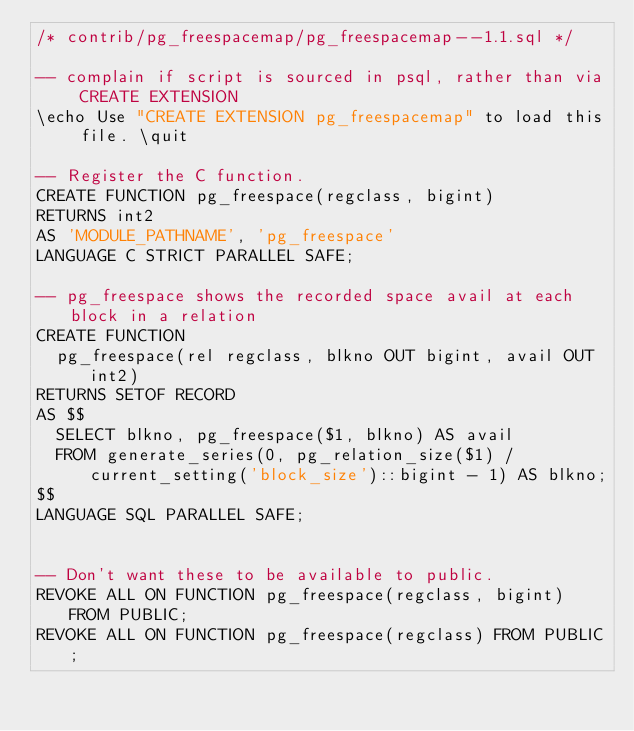<code> <loc_0><loc_0><loc_500><loc_500><_SQL_>/* contrib/pg_freespacemap/pg_freespacemap--1.1.sql */

-- complain if script is sourced in psql, rather than via CREATE EXTENSION
\echo Use "CREATE EXTENSION pg_freespacemap" to load this file. \quit

-- Register the C function.
CREATE FUNCTION pg_freespace(regclass, bigint)
RETURNS int2
AS 'MODULE_PATHNAME', 'pg_freespace'
LANGUAGE C STRICT PARALLEL SAFE;

-- pg_freespace shows the recorded space avail at each block in a relation
CREATE FUNCTION
  pg_freespace(rel regclass, blkno OUT bigint, avail OUT int2)
RETURNS SETOF RECORD
AS $$
  SELECT blkno, pg_freespace($1, blkno) AS avail
  FROM generate_series(0, pg_relation_size($1) / current_setting('block_size')::bigint - 1) AS blkno;
$$
LANGUAGE SQL PARALLEL SAFE;


-- Don't want these to be available to public.
REVOKE ALL ON FUNCTION pg_freespace(regclass, bigint) FROM PUBLIC;
REVOKE ALL ON FUNCTION pg_freespace(regclass) FROM PUBLIC;
</code> 